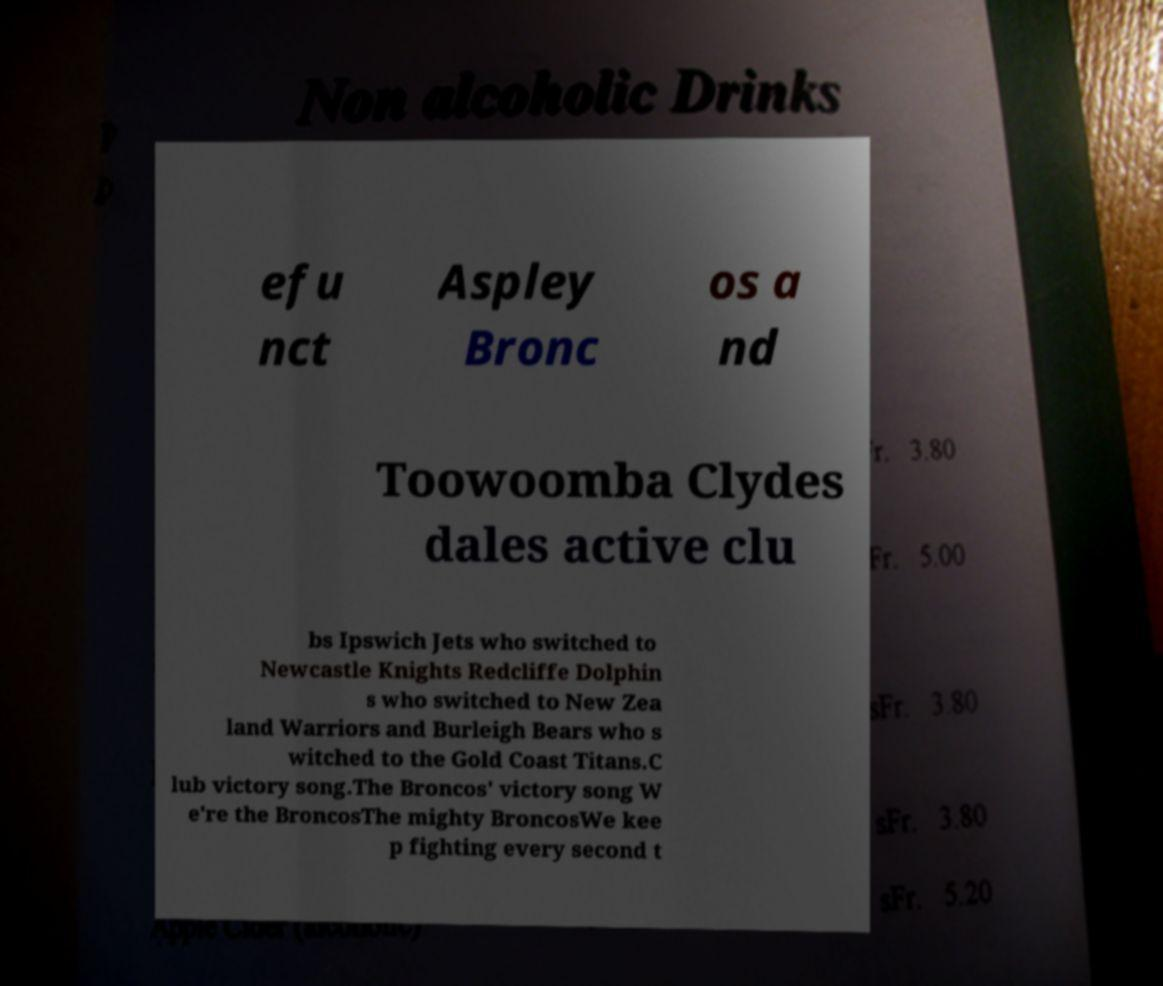What messages or text are displayed in this image? I need them in a readable, typed format. efu nct Aspley Bronc os a nd Toowoomba Clydes dales active clu bs Ipswich Jets who switched to Newcastle Knights Redcliffe Dolphin s who switched to New Zea land Warriors and Burleigh Bears who s witched to the Gold Coast Titans.C lub victory song.The Broncos' victory song W e're the BroncosThe mighty BroncosWe kee p fighting every second t 